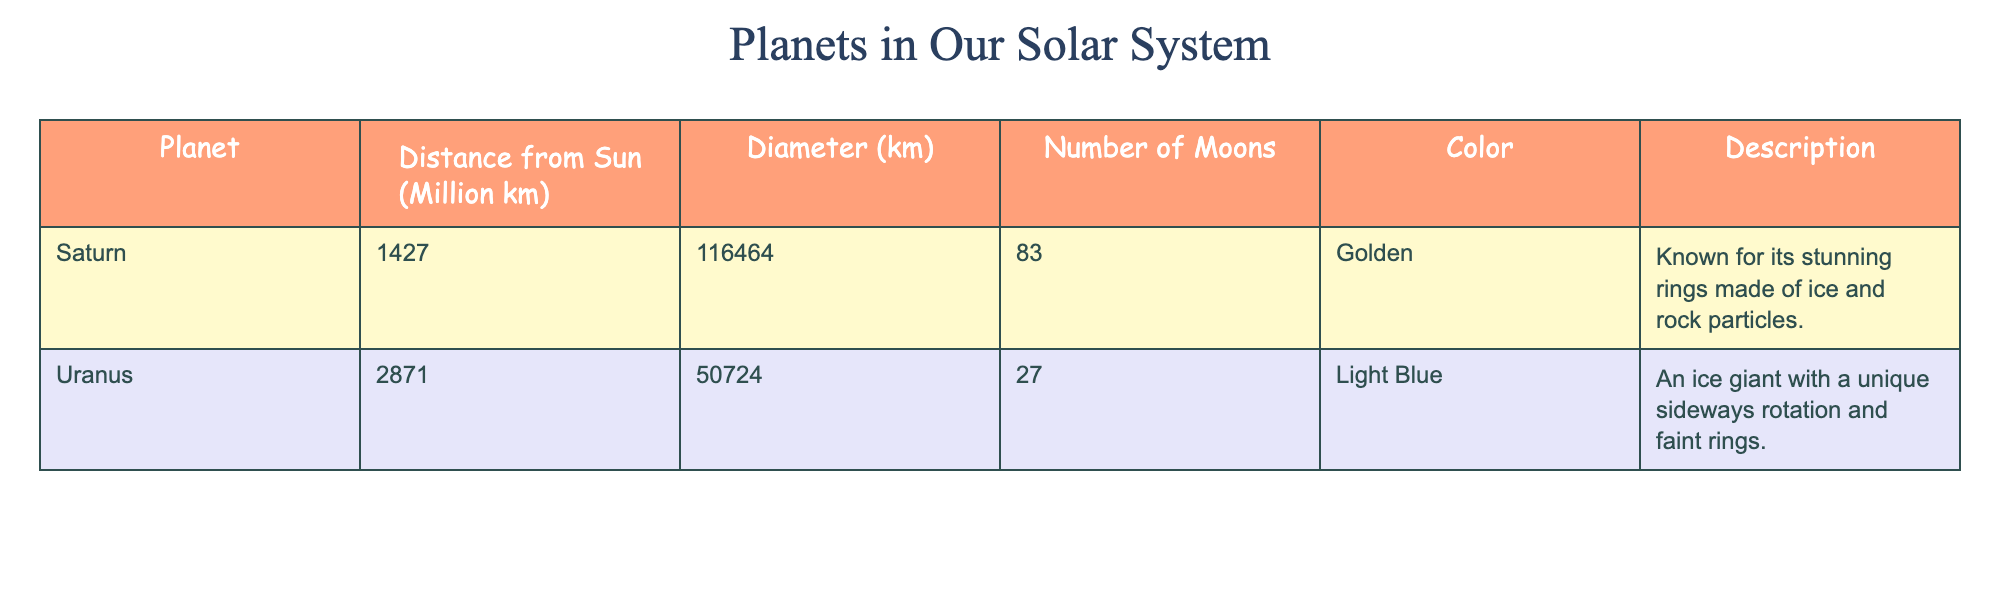What is the distance of Saturn from the Sun? The table shows that the distance of Saturn from the Sun is listed as 1427 million km.
Answer: 1427 million km How many moons does Uranus have? By looking at the table, I can see that Uranus has 27 moons mentioned in the data.
Answer: 27 moons Which planet is known for its stunning rings? The description for Saturn states that it is known for its stunning rings made of ice and rock particles.
Answer: Saturn What is the diameter of Uranus? The table indicates that the diameter of Uranus is 50,724 km.
Answer: 50,724 km How much farther is Uranus from the Sun than Saturn? The distance of Uranus is 2871 million km, and the distance of Saturn is 1427 million km. The difference can be calculated as 2871 - 1427 = 1444 million km.
Answer: 1444 million km What is the average diameter of Saturn and Uranus? To find the average, I first need to sum the diameters: 116,464 km (Saturn) + 50,724 km (Uranus) = 167,188 km. Then, I divide this total by 2 (the number of planets), so 167,188 km / 2 = 83,594 km.
Answer: 83,594 km Is Uranus an ice giant? The description for Uranus in the table states that it is an ice giant, which confirms this fact.
Answer: Yes Which planet has more moons, Saturn or Uranus? The table states that Saturn has 83 moons and Uranus has 27 moons. Since 83 is greater than 27, Saturn has more moons.
Answer: Saturn has more moons What color is Saturn? According to the table, Saturn has a golden color listed in the data.
Answer: Golden If you combine the distances of Saturn and Uranus from the Sun, what do you get? The distance of Saturn from the Sun is 1427 million km and Uranus is 2871 million km. Adding these together gives 1427 + 2871 = 4298 million km.
Answer: 4298 million km 